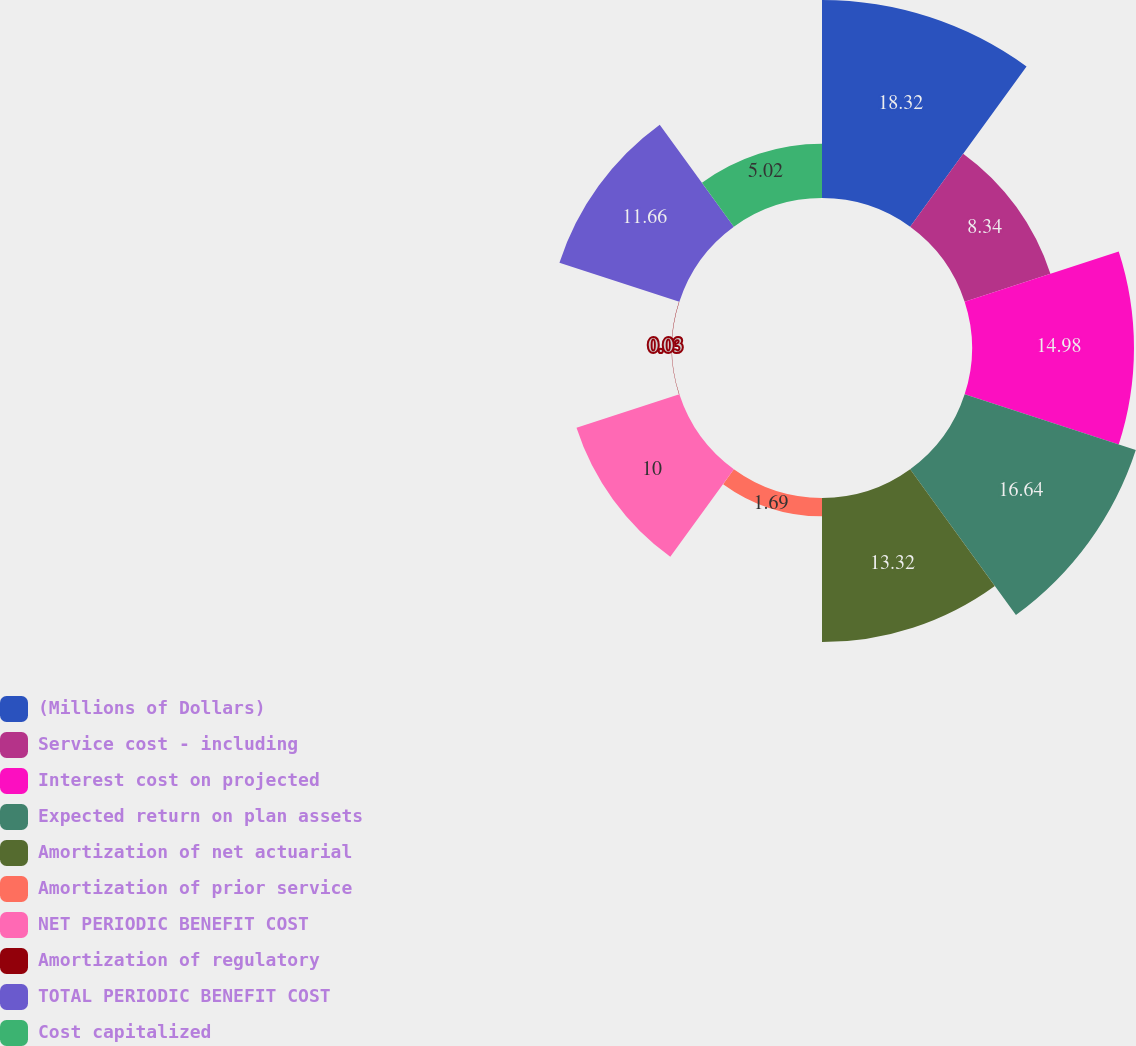Convert chart. <chart><loc_0><loc_0><loc_500><loc_500><pie_chart><fcel>(Millions of Dollars)<fcel>Service cost - including<fcel>Interest cost on projected<fcel>Expected return on plan assets<fcel>Amortization of net actuarial<fcel>Amortization of prior service<fcel>NET PERIODIC BENEFIT COST<fcel>Amortization of regulatory<fcel>TOTAL PERIODIC BENEFIT COST<fcel>Cost capitalized<nl><fcel>18.31%<fcel>8.34%<fcel>14.98%<fcel>16.64%<fcel>13.32%<fcel>1.69%<fcel>10.0%<fcel>0.03%<fcel>11.66%<fcel>5.02%<nl></chart> 